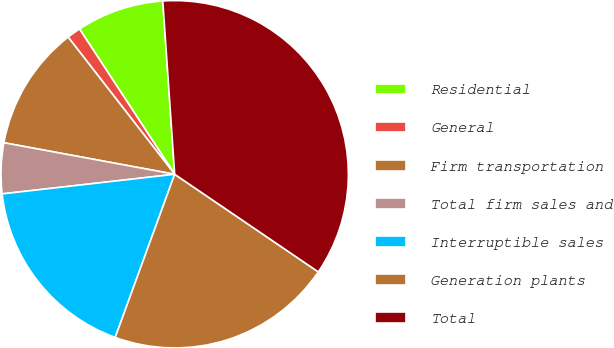Convert chart to OTSL. <chart><loc_0><loc_0><loc_500><loc_500><pie_chart><fcel>Residential<fcel>General<fcel>Firm transportation<fcel>Total firm sales and<fcel>Interruptible sales<fcel>Generation plants<fcel>Total<nl><fcel>8.14%<fcel>1.28%<fcel>11.58%<fcel>4.71%<fcel>17.63%<fcel>21.06%<fcel>35.59%<nl></chart> 